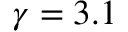<formula> <loc_0><loc_0><loc_500><loc_500>\gamma = 3 . 1</formula> 